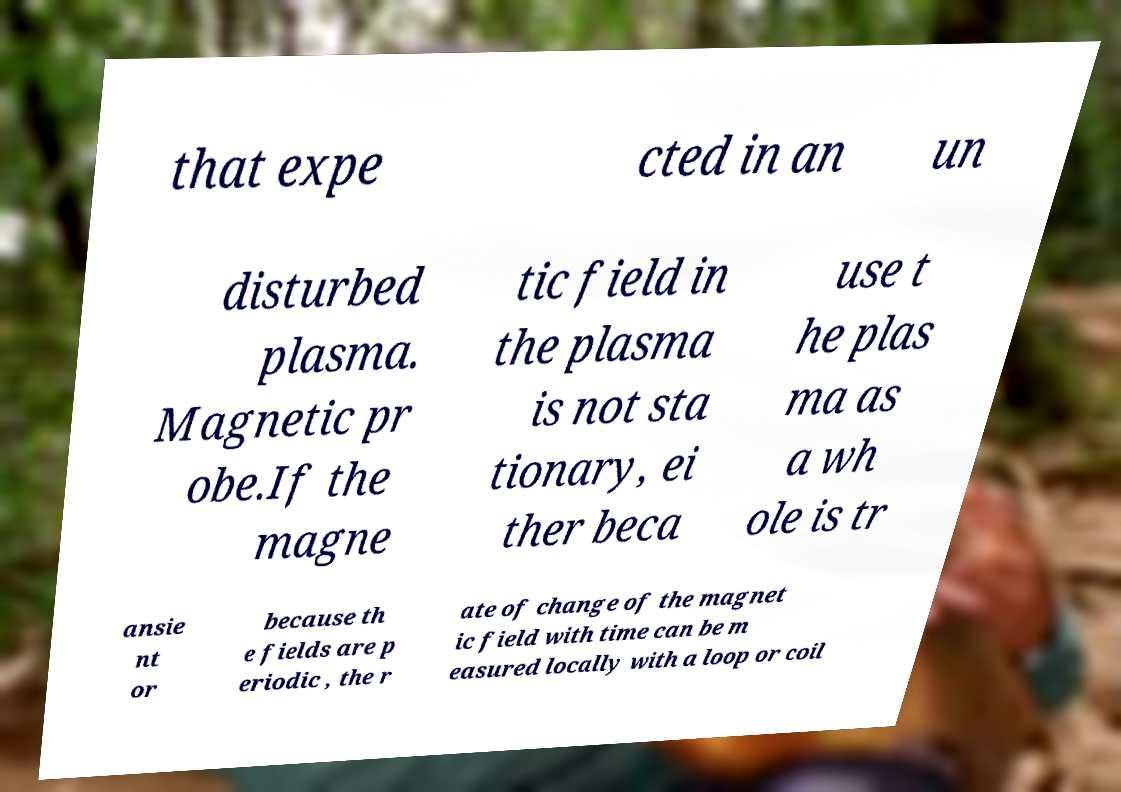Could you extract and type out the text from this image? that expe cted in an un disturbed plasma. Magnetic pr obe.If the magne tic field in the plasma is not sta tionary, ei ther beca use t he plas ma as a wh ole is tr ansie nt or because th e fields are p eriodic , the r ate of change of the magnet ic field with time can be m easured locally with a loop or coil 